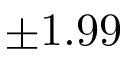Convert formula to latex. <formula><loc_0><loc_0><loc_500><loc_500>\pm 1 . 9 9</formula> 